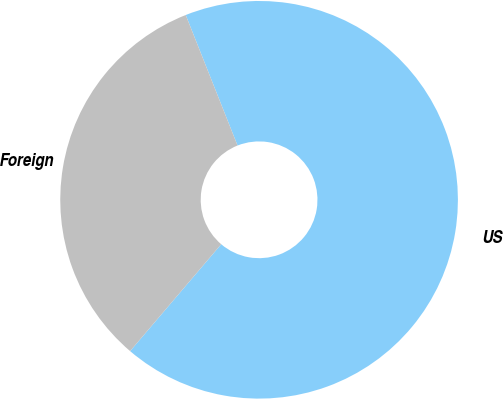Convert chart to OTSL. <chart><loc_0><loc_0><loc_500><loc_500><pie_chart><fcel>US<fcel>Foreign<nl><fcel>67.25%<fcel>32.75%<nl></chart> 